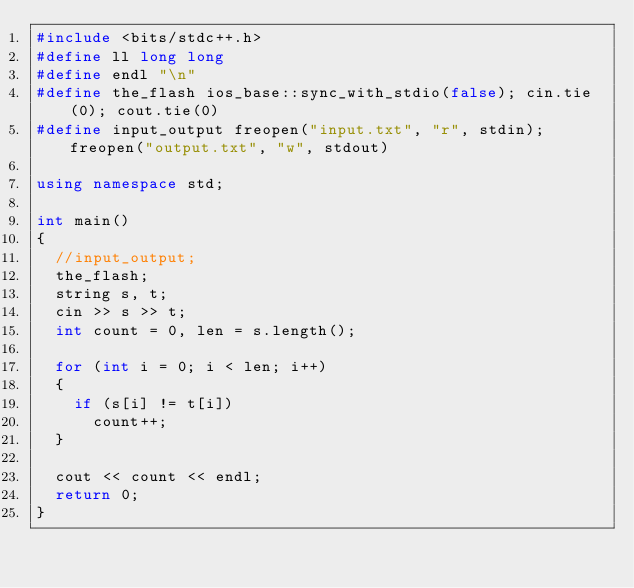<code> <loc_0><loc_0><loc_500><loc_500><_C++_>#include <bits/stdc++.h>
#define ll long long
#define endl "\n"
#define the_flash ios_base::sync_with_stdio(false); cin.tie(0); cout.tie(0)
#define input_output freopen("input.txt", "r", stdin); freopen("output.txt", "w", stdout)

using namespace std;

int main()
{
	//input_output;
	the_flash;
	string s, t;
	cin >> s >> t;
	int count = 0, len = s.length();
	
	for (int i = 0; i < len; i++)
	{
		if (s[i] != t[i])
			count++;
	}
	
	cout << count << endl;
	return 0;
}
</code> 